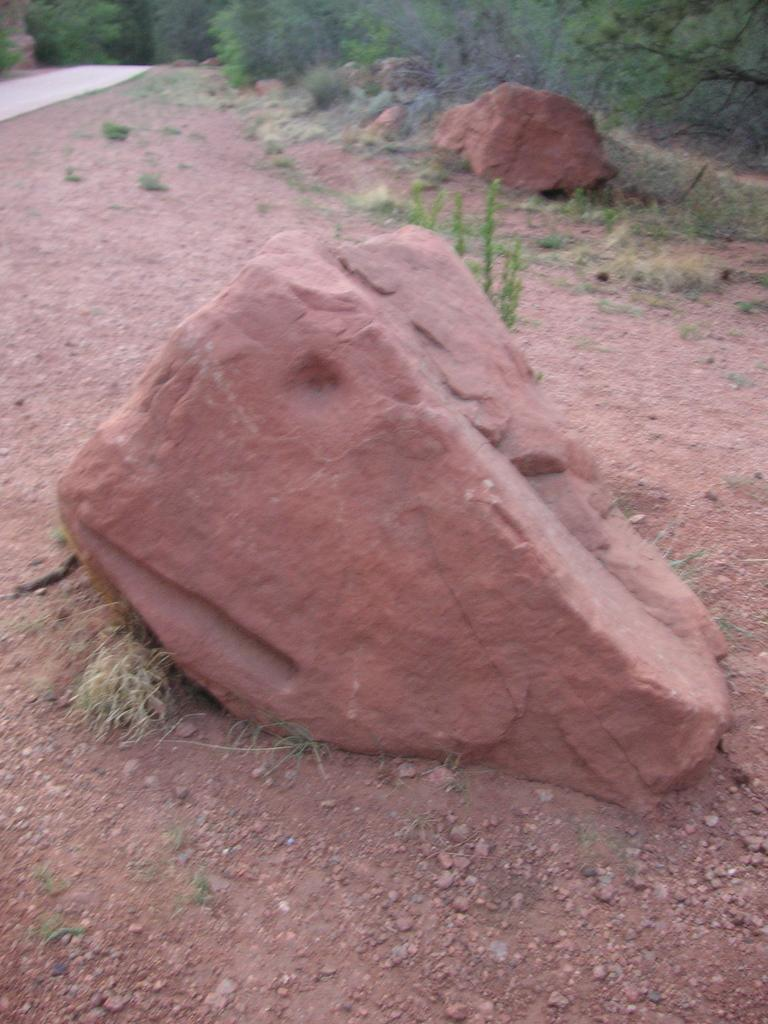What type of setting is depicted in the image? The image is an outside view. What objects can be seen on the ground in the image? There are two rocks on the ground. What type of vegetation is present in the image? There are plants in the image. What man-made structure can be seen in the top left of the image? There is a road in the top left of the image. What natural features are visible in the background of the image? There are many trees in the background of the image. What type of pot can be seen hanging from the trees in the image? There is no pot visible in the image, and no pots are hanging from the trees. 